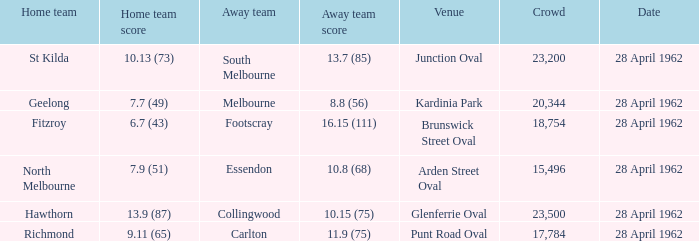I'm looking to parse the entire table for insights. Could you assist me with that? {'header': ['Home team', 'Home team score', 'Away team', 'Away team score', 'Venue', 'Crowd', 'Date'], 'rows': [['St Kilda', '10.13 (73)', 'South Melbourne', '13.7 (85)', 'Junction Oval', '23,200', '28 April 1962'], ['Geelong', '7.7 (49)', 'Melbourne', '8.8 (56)', 'Kardinia Park', '20,344', '28 April 1962'], ['Fitzroy', '6.7 (43)', 'Footscray', '16.15 (111)', 'Brunswick Street Oval', '18,754', '28 April 1962'], ['North Melbourne', '7.9 (51)', 'Essendon', '10.8 (68)', 'Arden Street Oval', '15,496', '28 April 1962'], ['Hawthorn', '13.9 (87)', 'Collingwood', '10.15 (75)', 'Glenferrie Oval', '23,500', '28 April 1962'], ['Richmond', '9.11 (65)', 'Carlton', '11.9 (75)', 'Punt Road Oval', '17,784', '28 April 1962']]} During a game where the home team scored 10.13 (73), what was the number of spectators? 23200.0. 